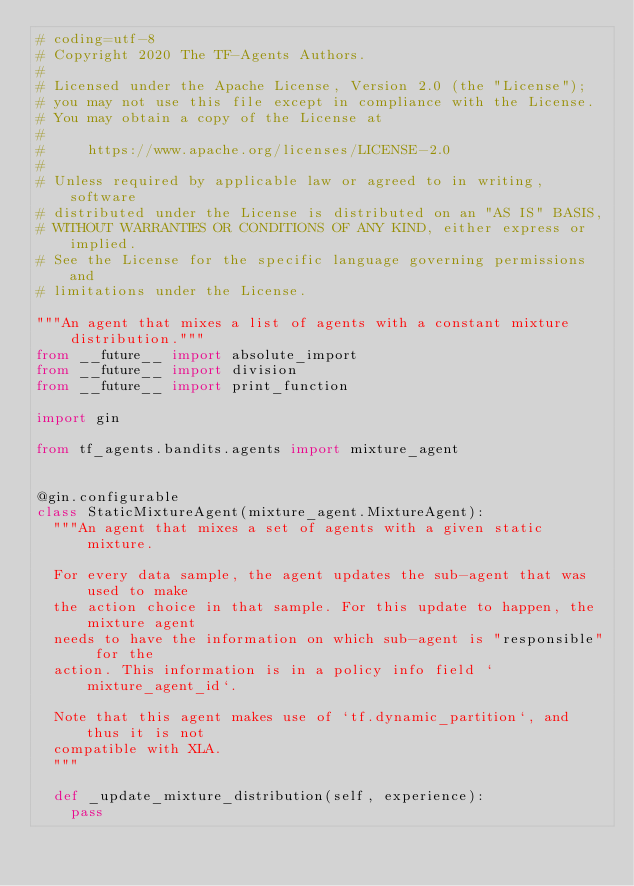<code> <loc_0><loc_0><loc_500><loc_500><_Python_># coding=utf-8
# Copyright 2020 The TF-Agents Authors.
#
# Licensed under the Apache License, Version 2.0 (the "License");
# you may not use this file except in compliance with the License.
# You may obtain a copy of the License at
#
#     https://www.apache.org/licenses/LICENSE-2.0
#
# Unless required by applicable law or agreed to in writing, software
# distributed under the License is distributed on an "AS IS" BASIS,
# WITHOUT WARRANTIES OR CONDITIONS OF ANY KIND, either express or implied.
# See the License for the specific language governing permissions and
# limitations under the License.

"""An agent that mixes a list of agents with a constant mixture distribution."""
from __future__ import absolute_import
from __future__ import division
from __future__ import print_function

import gin

from tf_agents.bandits.agents import mixture_agent


@gin.configurable
class StaticMixtureAgent(mixture_agent.MixtureAgent):
  """An agent that mixes a set of agents with a given static mixture.

  For every data sample, the agent updates the sub-agent that was used to make
  the action choice in that sample. For this update to happen, the mixture agent
  needs to have the information on which sub-agent is "responsible" for the
  action. This information is in a policy info field `mixture_agent_id`.

  Note that this agent makes use of `tf.dynamic_partition`, and thus it is not
  compatible with XLA.
  """

  def _update_mixture_distribution(self, experience):
    pass
</code> 